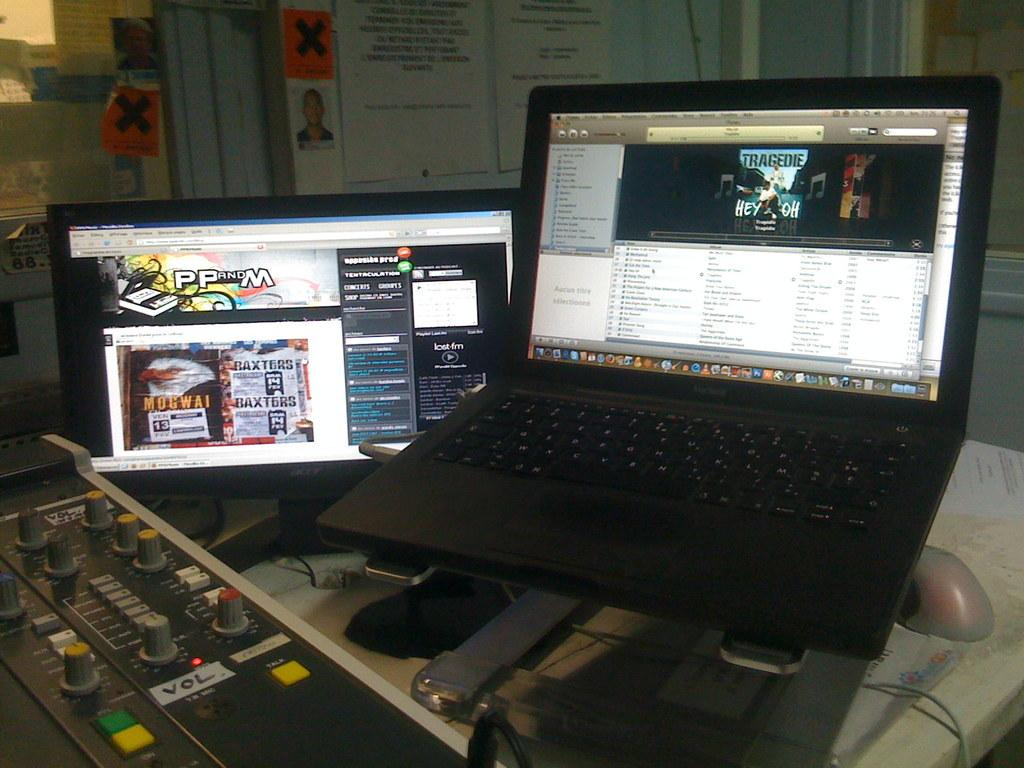Provide a one-sentence caption for the provided image. a black macbook open to a music tab. 